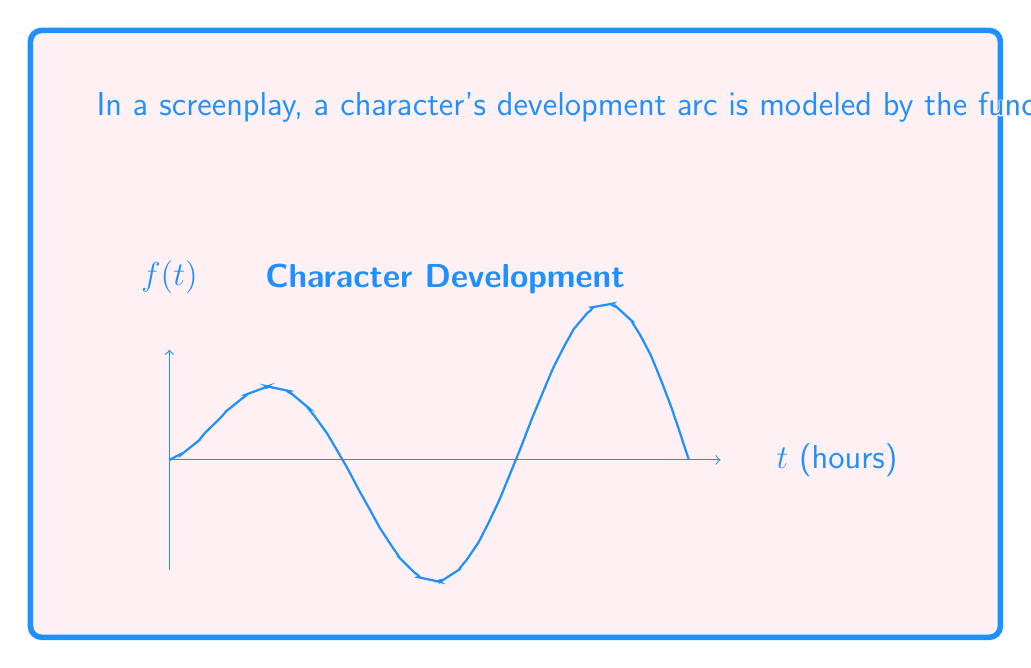Provide a solution to this math problem. To estimate the Lipschitz constant $L$ for the function $f(t) = \sqrt{t} \sin(t)$ on $[0, 3\pi]$, we'll use the fact that for a differentiable function, the Lipschitz constant is bounded by the maximum absolute value of its derivative on the interval.

Step 1: Find the derivative of $f(t)$.
$$f'(t) = \frac{1}{2\sqrt{t}} \sin(t) + \sqrt{t} \cos(t)$$

Step 2: Find the absolute value of $f'(t)$.
$$|f'(t)| = \left|\frac{1}{2\sqrt{t}} \sin(t) + \sqrt{t} \cos(t)\right|$$

Step 3: Use the triangle inequality to bound $|f'(t)|$.
$$|f'(t)| \leq \left|\frac{1}{2\sqrt{t}} \sin(t)\right| + |\sqrt{t} \cos(t)|$$

Step 4: Use the fact that $|\sin(t)| \leq 1$ and $|\cos(t)| \leq 1$ for all $t$.
$$|f'(t)| \leq \frac{1}{2\sqrt{t}} + \sqrt{t}$$

Step 5: Find the maximum value of this bound on $[0, 3\pi]$.
The function $\frac{1}{2\sqrt{t}} + \sqrt{t}$ has its maximum at $t = 1$ on $[0, 3\pi]$.

Step 6: Calculate the value at $t = 1$.
$$\left.\left(\frac{1}{2\sqrt{t}} + \sqrt{t}\right)\right|_{t=1} = \frac{1}{2} + 1 = \frac{3}{2}$$

Therefore, an estimate for the Lipschitz constant $L$ is $\frac{3}{2}$ or 1.5.
Answer: $L \approx \frac{3}{2}$ 